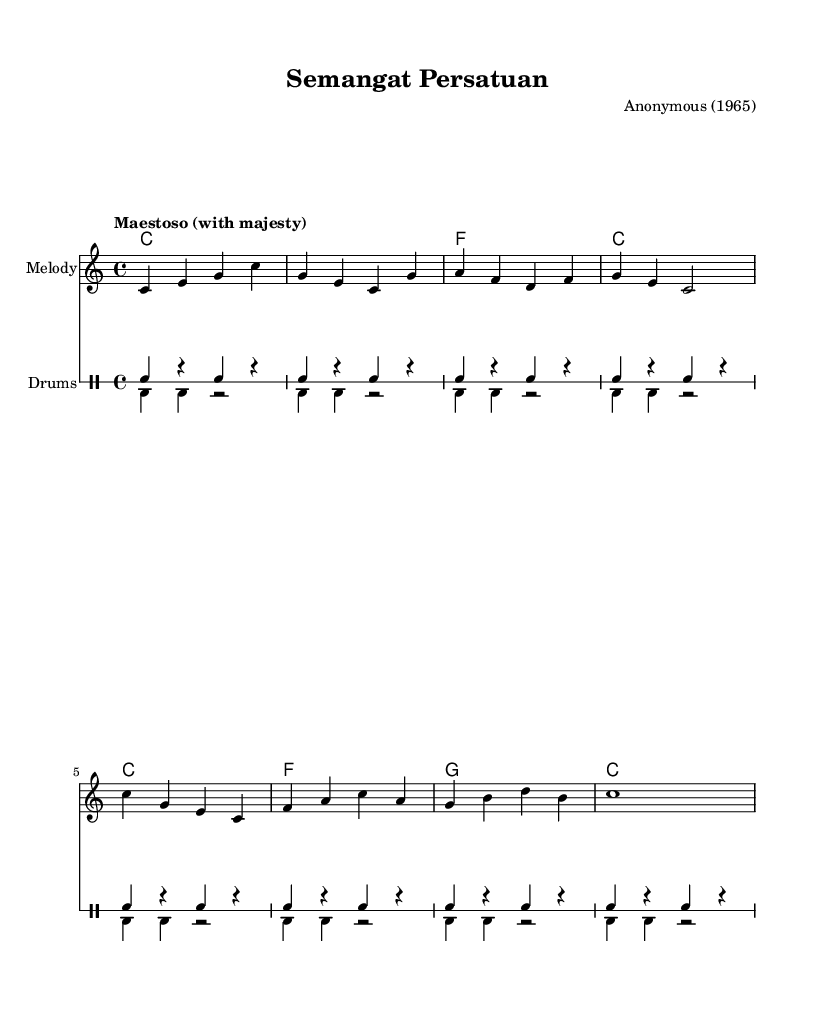What is the key signature of this music? The key signature is indicated at the beginning of the staff, showing no sharps or flats, which corresponds to C major.
Answer: C major What is the time signature of the music? The time signature, displayed at the beginning of the score, is shown as 4/4, indicating a common time with four beats per measure.
Answer: 4/4 What is the tempo marking for this piece? The tempo marking is described at the beginning as "Maestoso," which is typically interpreted as a majestic and stately pace, reinforcing the patriotic theme.
Answer: Maestoso How many measures are there in the melody? By counting the measures indicated by the bar lines in the melody, there are a total of 8 measures shown in the score.
Answer: 8 What lyric theme is represented in this piece? The lyrics reflect themes of unity and patriotism, emphasized by phrases like "In -- do -- ne -- sia ta -- nah air -- ku" referring to Indonesia, suggesting a national pride.
Answer: Unity and patriotism What type of ensemble is this music intended for? The score consists of a melody, harmonies, lyrics, and drums, indicating it is arranged for a vocal and instrumental ensemble typical of patriotic marches.
Answer: Vocal and instrumental ensemble What year was this piece composed? The score indicates that it was composed in the year 1965, which was a significant period for patriotic sentiment in Indonesia.
Answer: 1965 